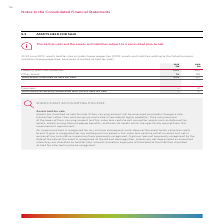According to Woolworths Limited's financial document, When are assets classified as held for sale? Assets are classified as held for sale if their carrying amount will be recovered principally through a sale transaction rather than continuing use and a sale is considered highly probable.. The document states: "Assets are classified as held for sale if their carrying amount will be recovered principally through a sale transaction rather than continuing use an..." Also, When is an impairment loss recognised? An impairment loss is recognised for any initial or subsequent write-down of the asset to fair value less costs to sell.. The document states: "An impairment loss is recognised for any initial or subsequent write-down of the asset to fair value less costs to sell. A gain is recognised for any ..." Also, What is the total assets classified as held for sale in 2019? According to the financial document, 225 (in millions). The relevant text states: "s 16 155 Total assets classified as held for sale 225 821..." Also, can you calculate: What is the difference in total assets classified as held for sale between 2018 and 2019? Based on the calculation: 821 - 225 , the result is 596 (in millions). This is based on the information: "s 16 155 Total assets classified as held for sale 225 821 155 Total assets classified as held for sale 225 821..." The key data points involved are: 225, 821. Also, can you calculate: What is the difference in other assets between 2018 and 2019? Based on the calculation: 155 - 16 , the result is 139 (in millions). This is based on the information: "roperty, plant and equipment 209 666 Other assets 16 155 Total assets classified as held for sale 225 821 erty, plant and equipment 209 666 Other assets 16 155 Total assets classified as held for sale..." The key data points involved are: 155, 16. Also, can you calculate: What is the percentage change in property, plant and equipment between 2018 and 2019? To answer this question, I need to perform calculations using the financial data. The calculation is: (666 - 209)/666 , which equals 68.62 (percentage). This is based on the information: "Property, plant and equipment 209 666 Other assets 16 155 Total assets classified as held for sale 225 821 Property, plant and equipment 209 666 Other assets 16 155 Total assets classified as held for..." The key data points involved are: 209, 666. 